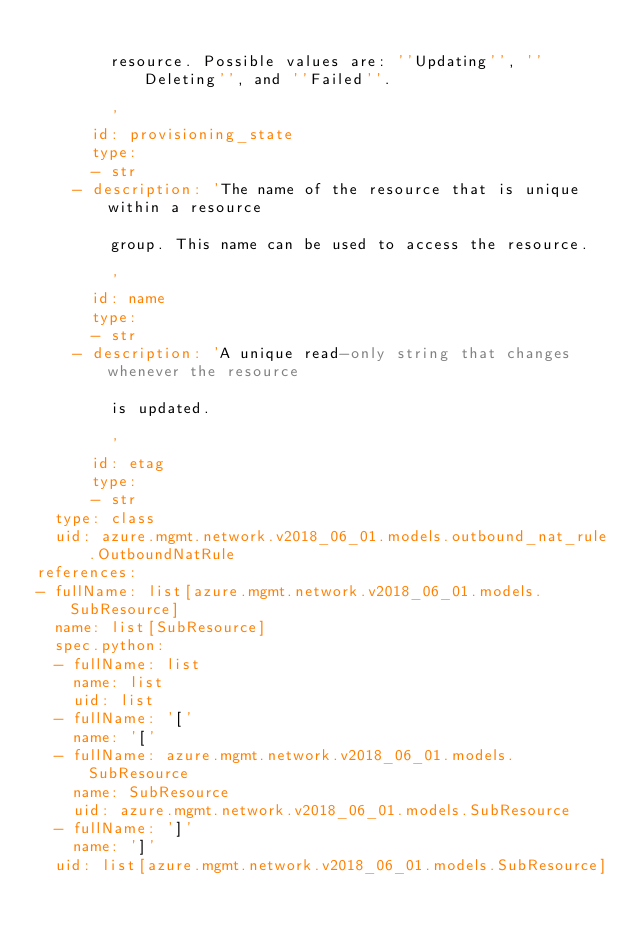Convert code to text. <code><loc_0><loc_0><loc_500><loc_500><_YAML_>
        resource. Possible values are: ''Updating'', ''Deleting'', and ''Failed''.

        '
      id: provisioning_state
      type:
      - str
    - description: 'The name of the resource that is unique within a resource

        group. This name can be used to access the resource.

        '
      id: name
      type:
      - str
    - description: 'A unique read-only string that changes whenever the resource

        is updated.

        '
      id: etag
      type:
      - str
  type: class
  uid: azure.mgmt.network.v2018_06_01.models.outbound_nat_rule.OutboundNatRule
references:
- fullName: list[azure.mgmt.network.v2018_06_01.models.SubResource]
  name: list[SubResource]
  spec.python:
  - fullName: list
    name: list
    uid: list
  - fullName: '['
    name: '['
  - fullName: azure.mgmt.network.v2018_06_01.models.SubResource
    name: SubResource
    uid: azure.mgmt.network.v2018_06_01.models.SubResource
  - fullName: ']'
    name: ']'
  uid: list[azure.mgmt.network.v2018_06_01.models.SubResource]
</code> 